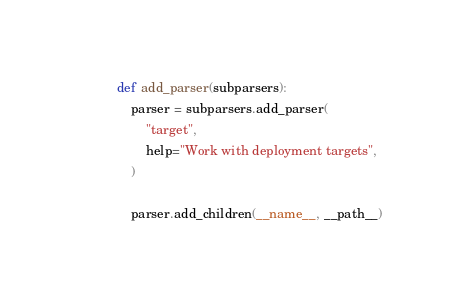<code> <loc_0><loc_0><loc_500><loc_500><_Python_>def add_parser(subparsers):
    parser = subparsers.add_parser(
        "target",
        help="Work with deployment targets",
    )

    parser.add_children(__name__, __path__)
</code> 